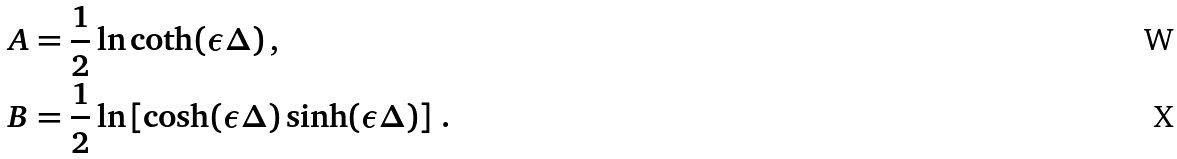Convert formula to latex. <formula><loc_0><loc_0><loc_500><loc_500>A & = \frac { 1 } { 2 } \ln \coth ( \epsilon \Delta ) \, , \\ B & = \frac { 1 } { 2 } \ln \left [ \cosh ( \epsilon \Delta ) \sinh ( \epsilon \Delta ) \right ] \, .</formula> 